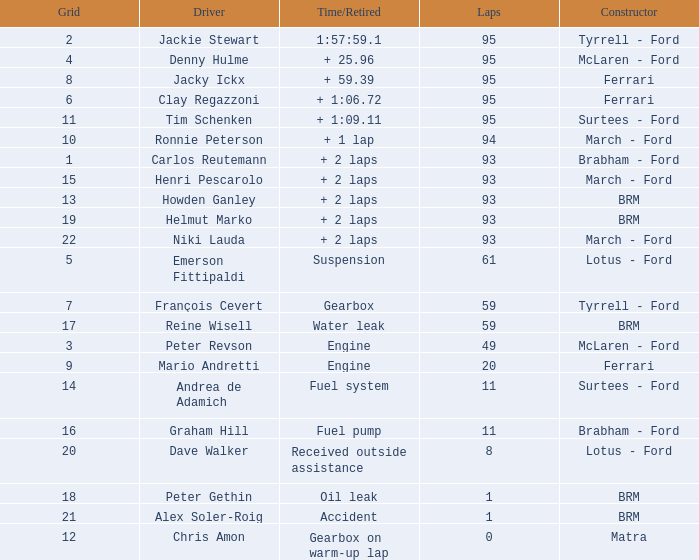What is the total number of grids for peter gethin? 18.0. 